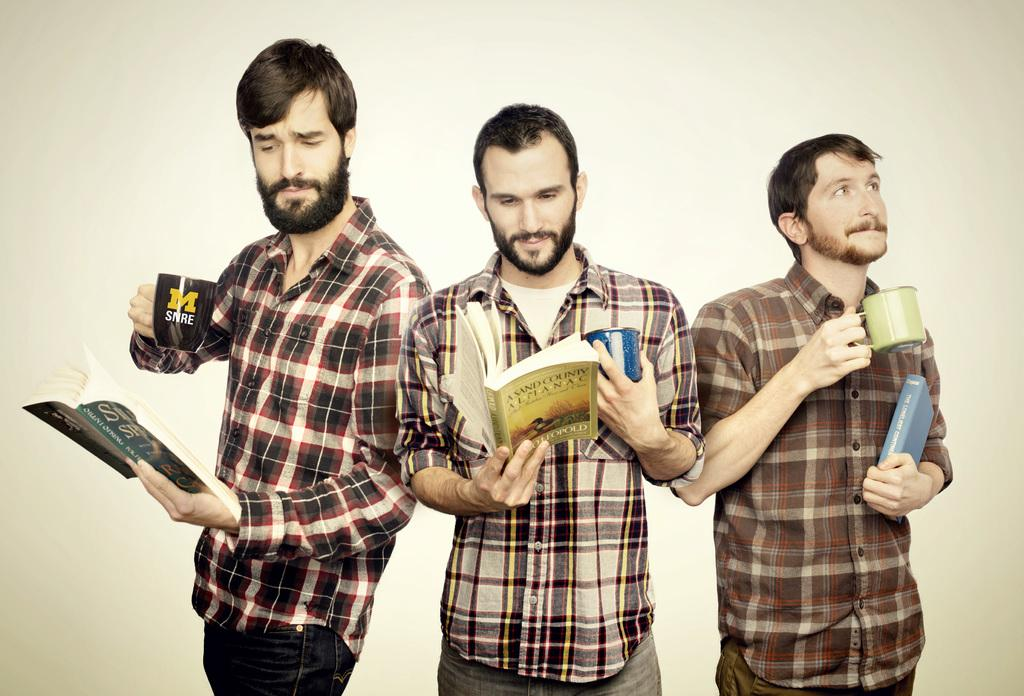How many people are in the image? There are three men in the image. What are the men holding in their hands? The men are holding books and cups. What type of wrench is the man using to open the book in the image? There is no wrench present in the image, and the men are not using any tools to open the books. 